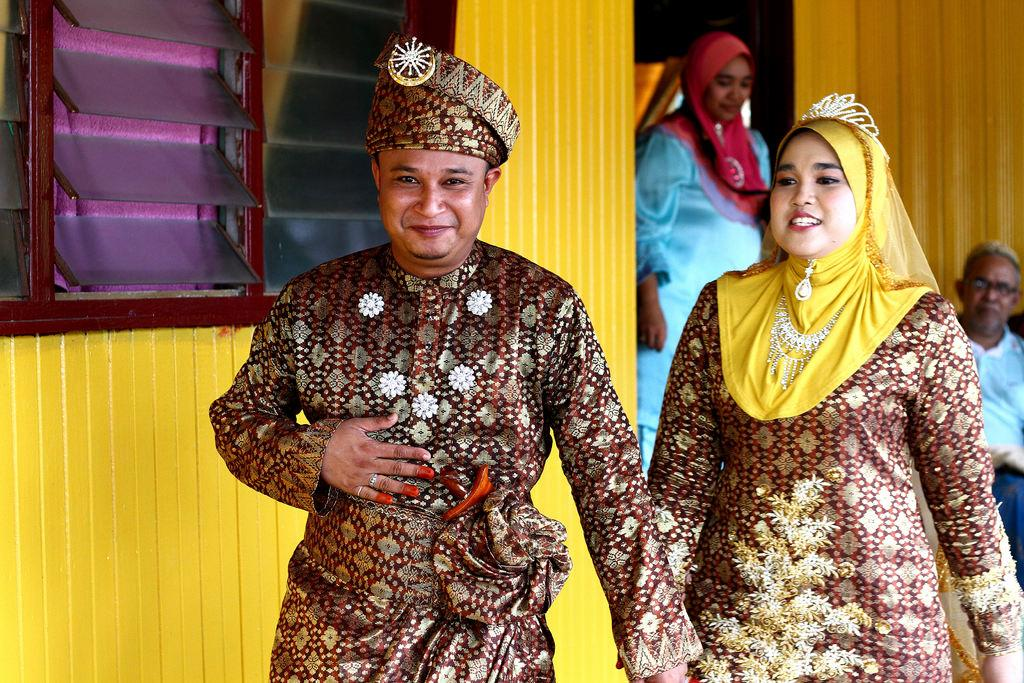What can be seen in the image? There is a group of people in the image. What are the people wearing? The people are wearing blue, white, yellow, and maroon-colored dresses. What is visible in the background of the image? There is a building in the background of the image. What feature does the building have? The building has windows. What type of harmony is being sung by the people in the image? There is no indication in the image that the people are singing or producing any sound, so it cannot be determined if they are singing in harmony. 